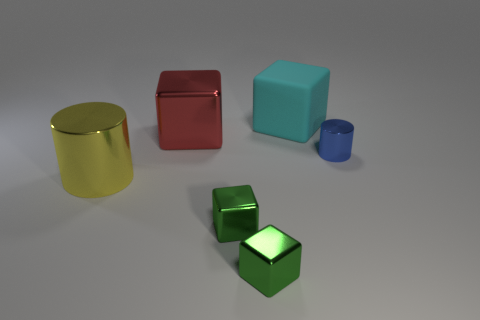Is the number of shiny cylinders that are to the right of the blue metal cylinder greater than the number of big gray blocks?
Your answer should be very brief. No. Is the yellow thing the same shape as the cyan thing?
Your response must be concise. No. How many other blue objects have the same material as the small blue object?
Give a very brief answer. 0. There is a cyan matte thing that is the same shape as the big red thing; what is its size?
Keep it short and to the point. Large. Is the size of the yellow cylinder the same as the cyan cube?
Keep it short and to the point. Yes. The thing left of the big metallic thing that is behind the small metal thing behind the big cylinder is what shape?
Keep it short and to the point. Cylinder. The other thing that is the same shape as the blue thing is what color?
Offer a very short reply. Yellow. What is the size of the shiny thing that is both behind the big yellow shiny object and in front of the red thing?
Your response must be concise. Small. What number of yellow shiny cylinders are in front of the shiny thing that is on the right side of the large cyan matte block right of the yellow shiny object?
Offer a very short reply. 1. How many tiny objects are blue cylinders or red metallic things?
Keep it short and to the point. 1. 